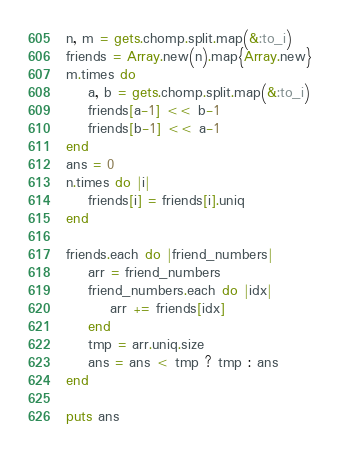<code> <loc_0><loc_0><loc_500><loc_500><_Ruby_>n, m = gets.chomp.split.map(&:to_i)
friends = Array.new(n).map{Array.new}
m.times do
    a, b = gets.chomp.split.map(&:to_i)
    friends[a-1] << b-1
    friends[b-1] << a-1
end
ans = 0
n.times do |i|
    friends[i] = friends[i].uniq
end

friends.each do |friend_numbers|
    arr = friend_numbers
    friend_numbers.each do |idx|
        arr += friends[idx]
    end
    tmp = arr.uniq.size
    ans = ans < tmp ? tmp : ans
end

puts ans</code> 